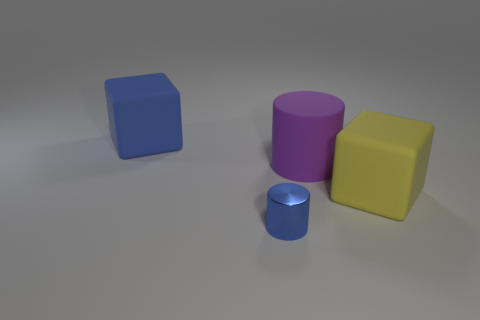What shape is the blue thing that is behind the blue metal object?
Give a very brief answer. Cube. What number of other objects are there of the same size as the purple thing?
Provide a succinct answer. 2. Do the blue object that is on the left side of the metallic cylinder and the big rubber object on the right side of the large purple rubber cylinder have the same shape?
Provide a succinct answer. Yes. There is a blue metal object; what number of big rubber objects are to the right of it?
Keep it short and to the point. 2. There is a big rubber cube left of the big yellow thing; what color is it?
Your response must be concise. Blue. There is a large thing that is the same shape as the tiny blue shiny thing; what color is it?
Provide a succinct answer. Purple. Is there anything else of the same color as the metal thing?
Ensure brevity in your answer.  Yes. Is the number of blocks greater than the number of large things?
Offer a very short reply. No. Are the big blue object and the purple cylinder made of the same material?
Provide a short and direct response. Yes. How many things have the same material as the blue cube?
Your answer should be very brief. 2. 